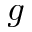Convert formula to latex. <formula><loc_0><loc_0><loc_500><loc_500>g</formula> 